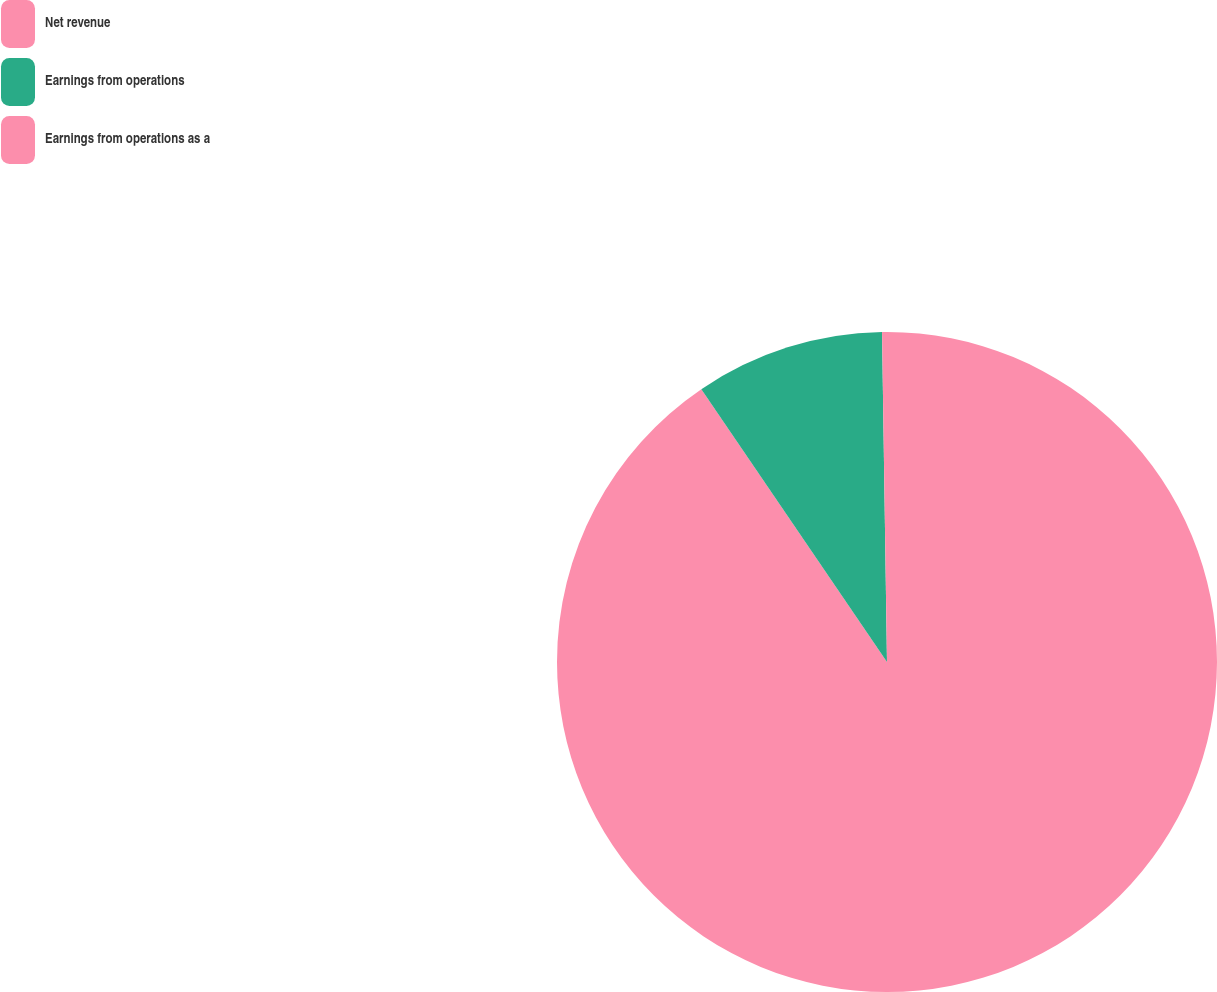Convert chart to OTSL. <chart><loc_0><loc_0><loc_500><loc_500><pie_chart><fcel>Net revenue<fcel>Earnings from operations<fcel>Earnings from operations as a<nl><fcel>90.49%<fcel>9.27%<fcel>0.24%<nl></chart> 